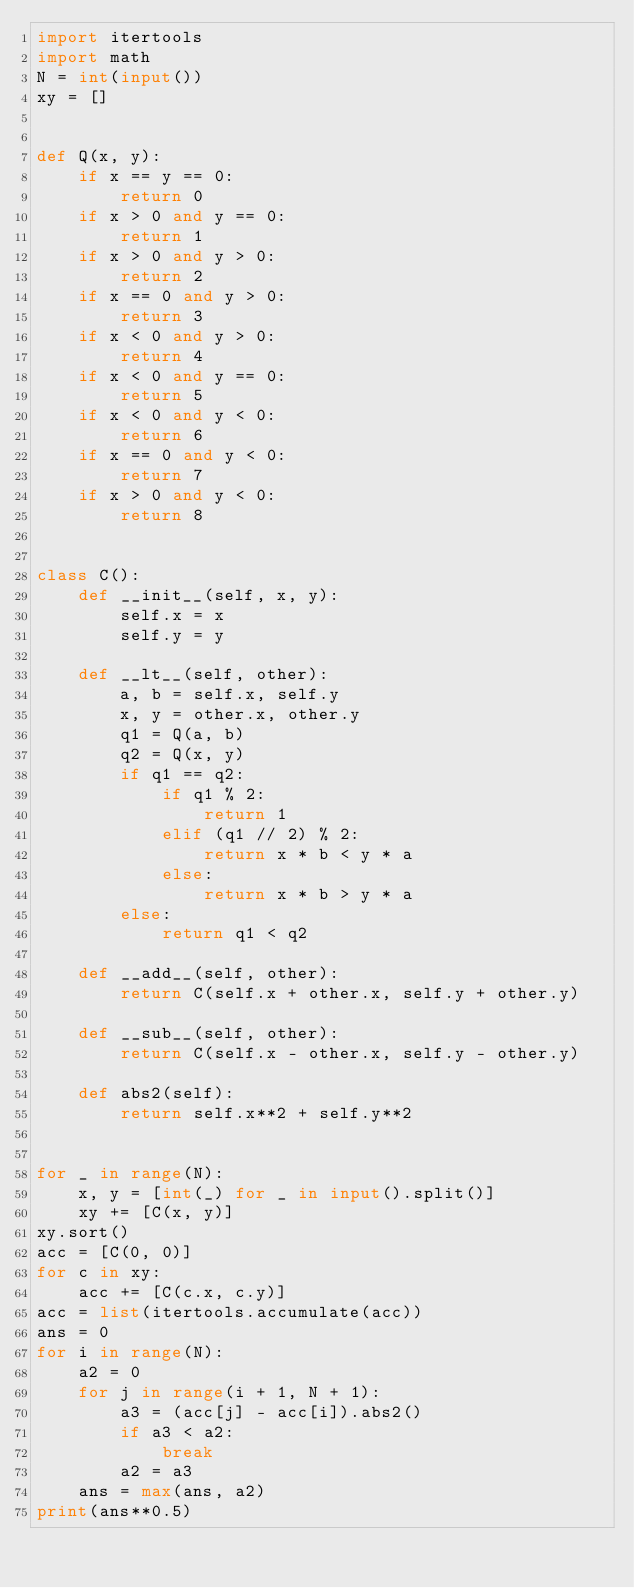<code> <loc_0><loc_0><loc_500><loc_500><_Python_>import itertools
import math
N = int(input())
xy = []


def Q(x, y):
    if x == y == 0:
        return 0
    if x > 0 and y == 0:
        return 1
    if x > 0 and y > 0:
        return 2
    if x == 0 and y > 0:
        return 3
    if x < 0 and y > 0:
        return 4
    if x < 0 and y == 0:
        return 5
    if x < 0 and y < 0:
        return 6
    if x == 0 and y < 0:
        return 7
    if x > 0 and y < 0:
        return 8


class C():
    def __init__(self, x, y):
        self.x = x
        self.y = y

    def __lt__(self, other):
        a, b = self.x, self.y
        x, y = other.x, other.y
        q1 = Q(a, b)
        q2 = Q(x, y)
        if q1 == q2:
            if q1 % 2:
                return 1
            elif (q1 // 2) % 2:
                return x * b < y * a
            else:
                return x * b > y * a
        else:
            return q1 < q2

    def __add__(self, other):
        return C(self.x + other.x, self.y + other.y)

    def __sub__(self, other):
        return C(self.x - other.x, self.y - other.y)

    def abs2(self):
        return self.x**2 + self.y**2


for _ in range(N):
    x, y = [int(_) for _ in input().split()]
    xy += [C(x, y)]
xy.sort()
acc = [C(0, 0)]
for c in xy:
    acc += [C(c.x, c.y)]
acc = list(itertools.accumulate(acc))
ans = 0
for i in range(N):
    a2 = 0
    for j in range(i + 1, N + 1):
        a3 = (acc[j] - acc[i]).abs2()
        if a3 < a2:
            break
        a2 = a3
    ans = max(ans, a2)
print(ans**0.5)
</code> 